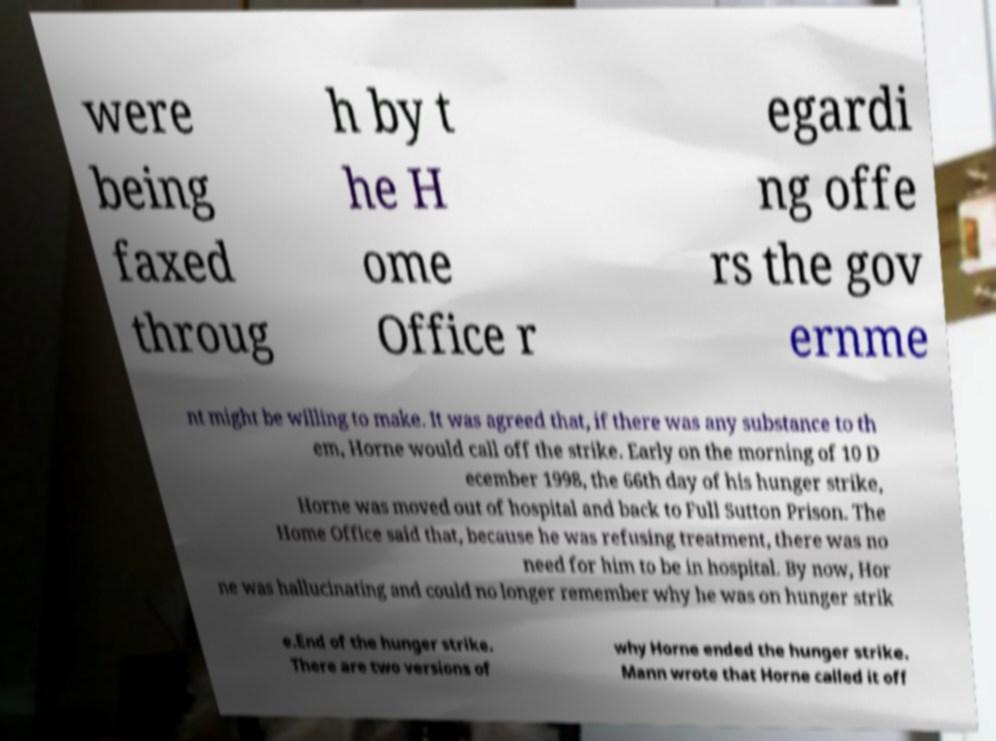I need the written content from this picture converted into text. Can you do that? were being faxed throug h by t he H ome Office r egardi ng offe rs the gov ernme nt might be willing to make. It was agreed that, if there was any substance to th em, Horne would call off the strike. Early on the morning of 10 D ecember 1998, the 66th day of his hunger strike, Horne was moved out of hospital and back to Full Sutton Prison. The Home Office said that, because he was refusing treatment, there was no need for him to be in hospital. By now, Hor ne was hallucinating and could no longer remember why he was on hunger strik e.End of the hunger strike. There are two versions of why Horne ended the hunger strike. Mann wrote that Horne called it off 